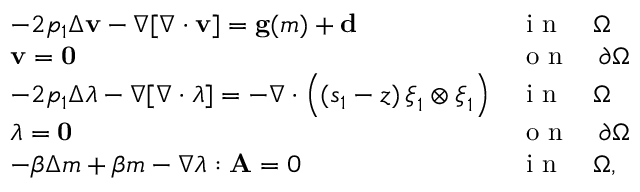<formula> <loc_0><loc_0><loc_500><loc_500>\begin{array} { l l } { - 2 p _ { 1 } \Delta v - \nabla [ \nabla \cdot v ] = g ( m ) + d } & { i n \quad \Omega } \\ { v = 0 } & { o n \quad \partial \Omega } \\ { - 2 p _ { 1 } \Delta \lambda - \nabla [ \nabla \cdot \lambda ] = - \nabla \cdot \left ( ( s _ { 1 } - z ) \, \xi _ { 1 } \otimes \xi _ { 1 } \right ) } & { i n \quad \Omega } \\ { \lambda = 0 } & { o n \quad \partial \Omega } \\ { - \beta \Delta m + \beta m - \nabla \lambda \colon A = 0 } & { i n \quad \Omega , } \end{array}</formula> 